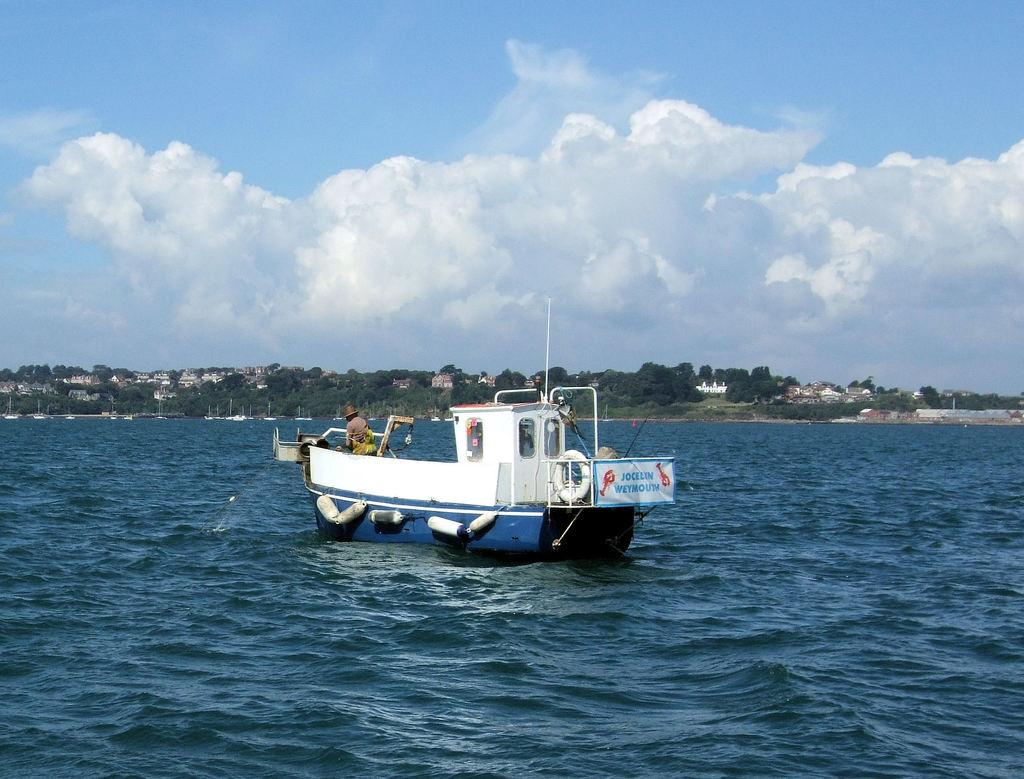What is the person in the image doing? There is a person standing on a boat in the image. Where is the boat located? The boat is on a river. What can be seen in the background of the image? There are buildings, trees, and the sky visible in the background of the image. How many frogs are sitting on the person's shoulder in the image? There are no frogs present in the image. What type of love is being expressed by the person on the boat? There is no indication of love or any emotion being expressed by the person in the image. 